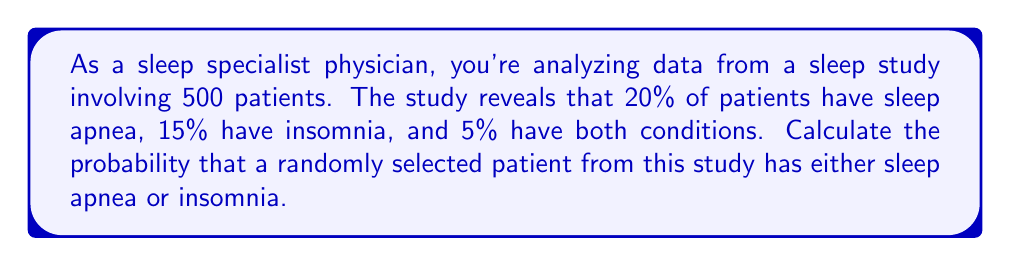Give your solution to this math problem. To solve this problem, we'll use the concept of probability and set theory. Let's break it down step by step:

1. Define our sets:
   Let A be the event of having sleep apnea
   Let I be the event of having insomnia

2. Given information:
   - Total patients: n = 500
   - P(A) = 20% = 0.20 (probability of sleep apnea)
   - P(I) = 15% = 0.15 (probability of insomnia)
   - P(A ∩ I) = 5% = 0.05 (probability of having both conditions)

3. We need to find P(A ∪ I), the probability of having either sleep apnea or insomnia (or both).

4. We can use the addition rule of probability:
   $$ P(A \cup I) = P(A) + P(I) - P(A \cap I) $$

5. Substituting the given values:
   $$ P(A \cup I) = 0.20 + 0.15 - 0.05 $$

6. Calculate:
   $$ P(A \cup I) = 0.30 $$

7. Convert to percentage:
   0.30 * 100 = 30%

Therefore, the probability that a randomly selected patient has either sleep apnea or insomnia is 30% or 0.30.
Answer: 30% or 0.30 